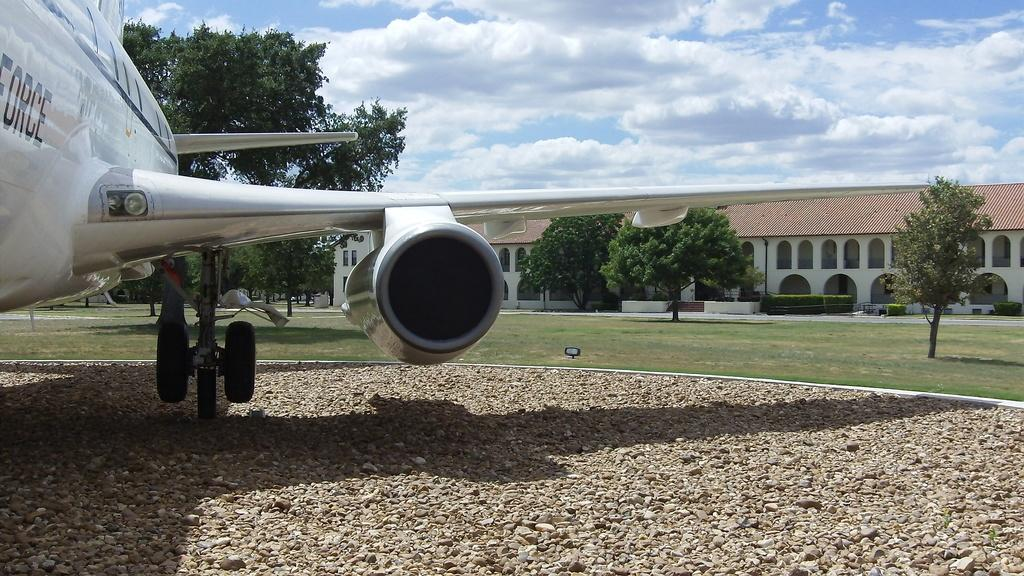What type of structure is visible in the image? There is a building in the image. What architectural feature can be seen in the building? There are arches in the image. What type of vegetation is present in the image? There are trees and grass in the image. What mode of transportation is visible in the image? There is an airplane in the image. What type of material is present in the image? There are stones in the image. What is the weather like in the image? The sky is cloudy in the image. What day of the week is it in the image? The day of the week is not mentioned or visible in the image. Whose chin can be seen in the image? There are no people or body parts visible in the image. 